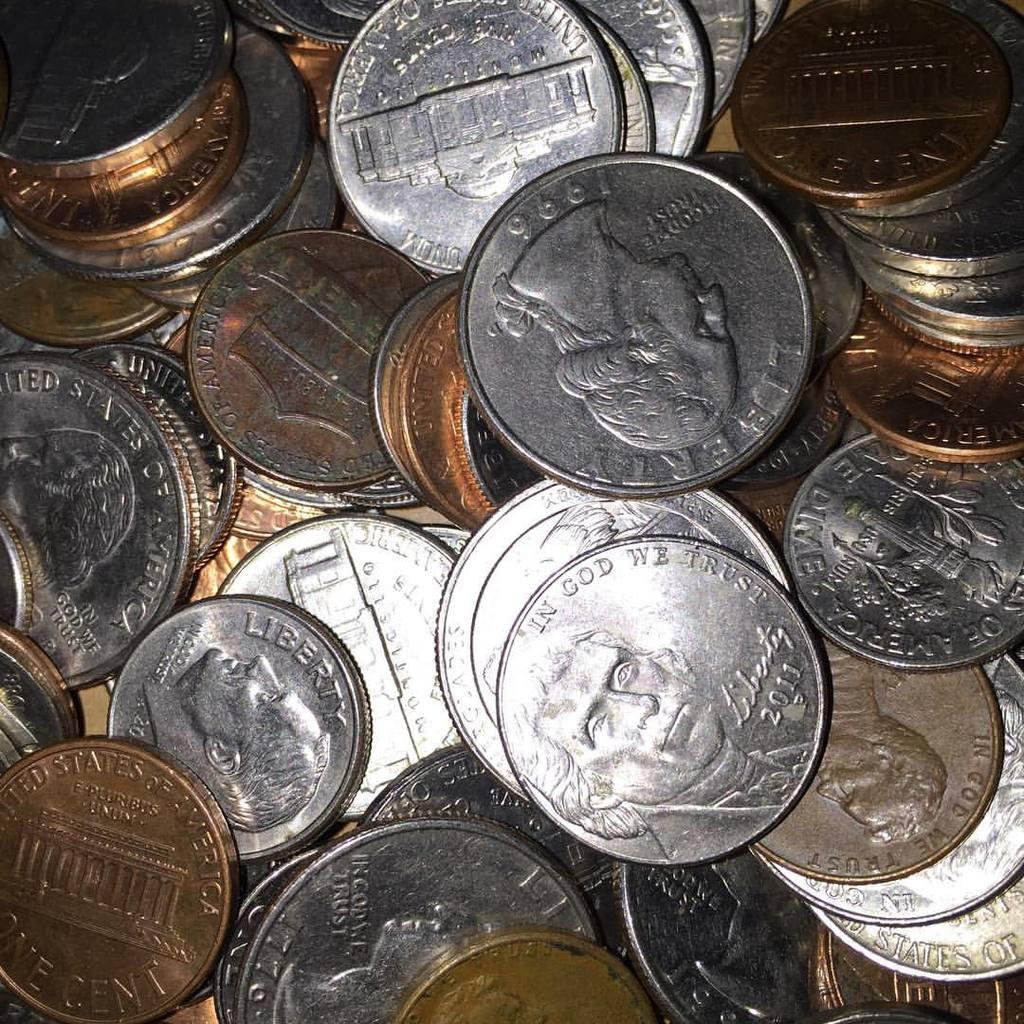<image>
Summarize the visual content of the image. many American coins in bronze and silver reading Liberty and In God We Trust 